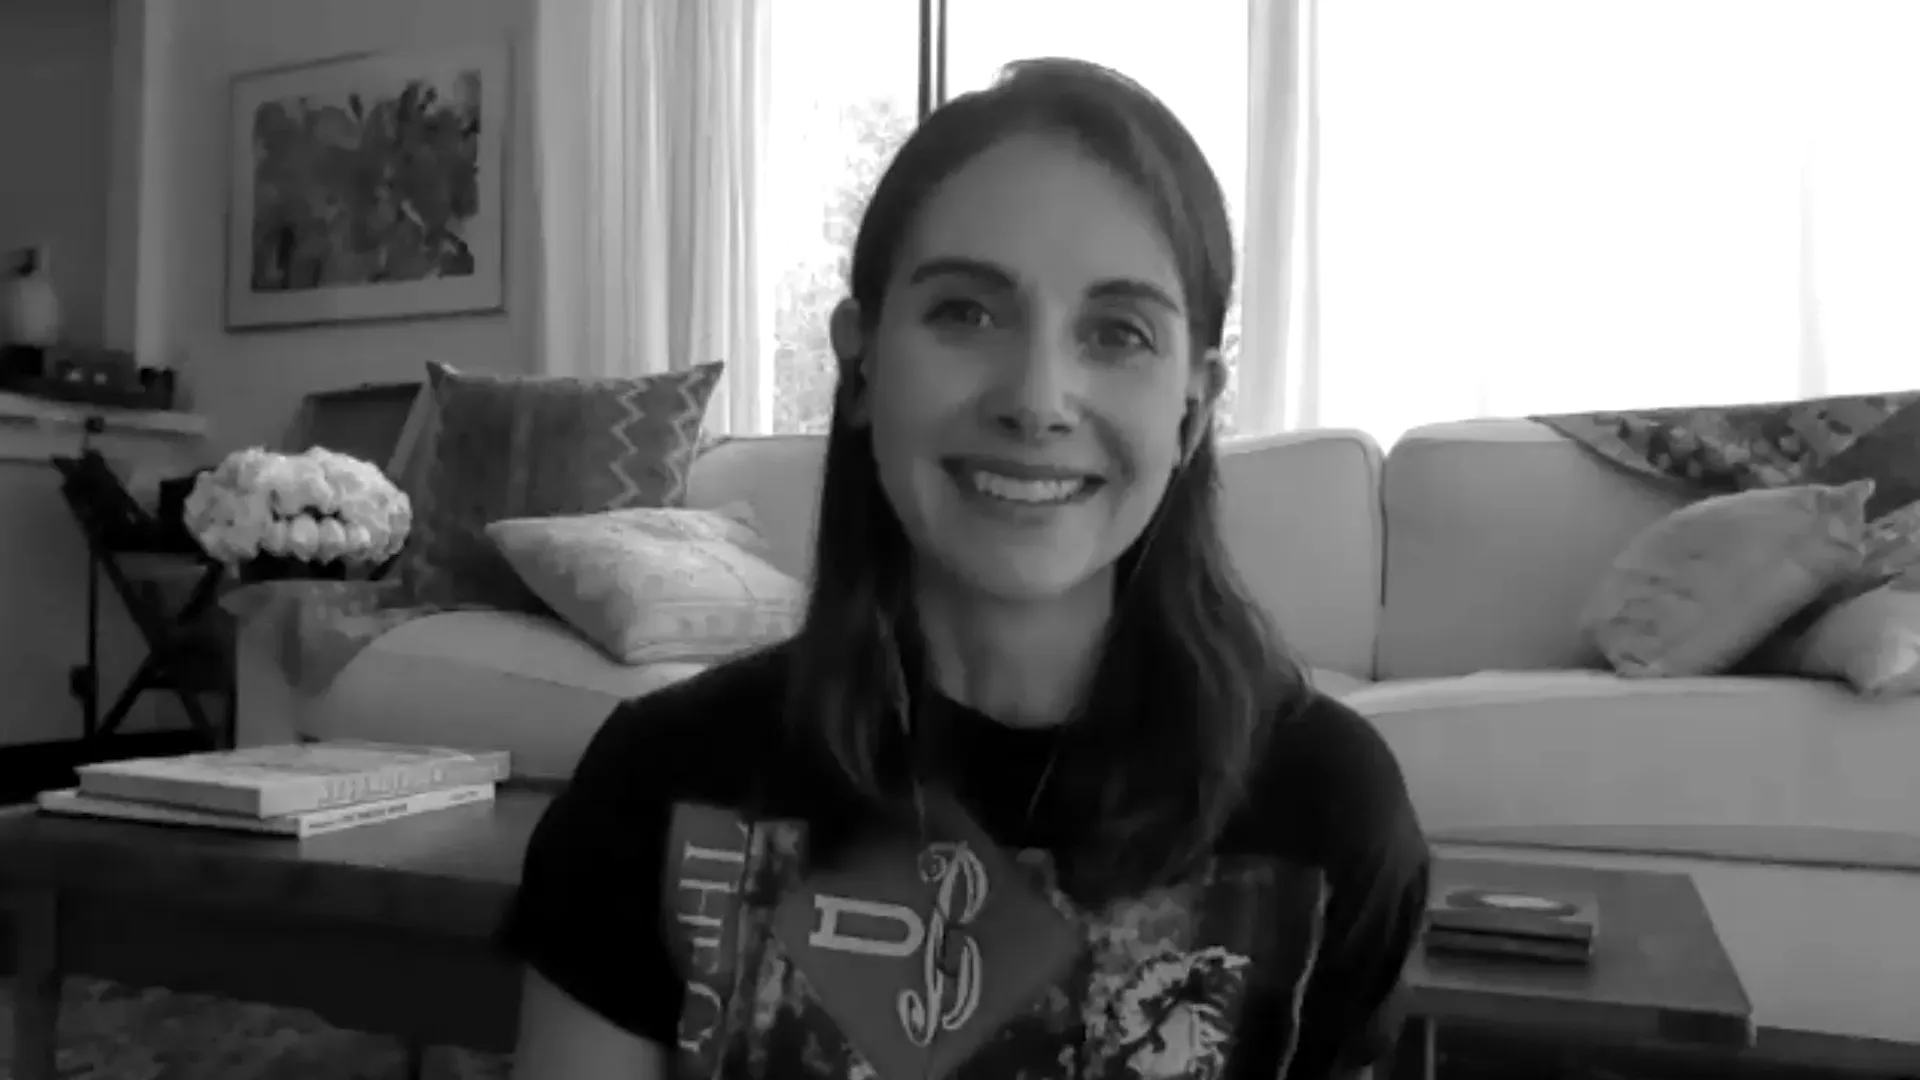Can you tell me more about the room's decorations? The room is decorated thoughtfully, blending comfort and style effortlessly. There's a large, elegant couch with plush pillows arranged neatly. A coffee table in front of the couch holds a few stacked books and a vase filled with fresh flowers, adding a personal touch and a hint of nature. A bookshelf filled with various books stands nearby, suggesting a love for reading and intellectual pursuits. The large window lets in ample natural light, brightening the space and highlighting its tasteful decor. 